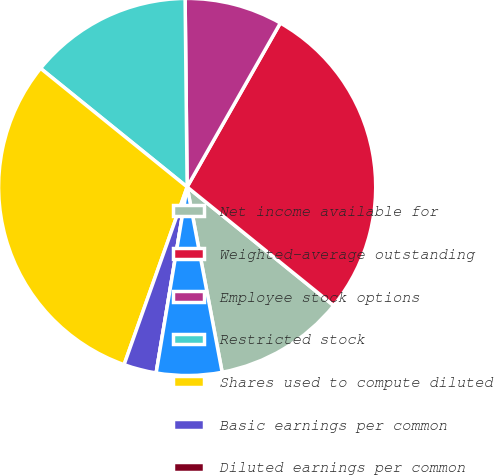Convert chart to OTSL. <chart><loc_0><loc_0><loc_500><loc_500><pie_chart><fcel>Net income available for<fcel>Weighted-average outstanding<fcel>Employee stock options<fcel>Restricted stock<fcel>Shares used to compute diluted<fcel>Basic earnings per common<fcel>Diluted earnings per common<fcel>Number of antidilutive stock<nl><fcel>11.2%<fcel>27.6%<fcel>8.4%<fcel>14.0%<fcel>30.4%<fcel>2.8%<fcel>0.0%<fcel>5.6%<nl></chart> 